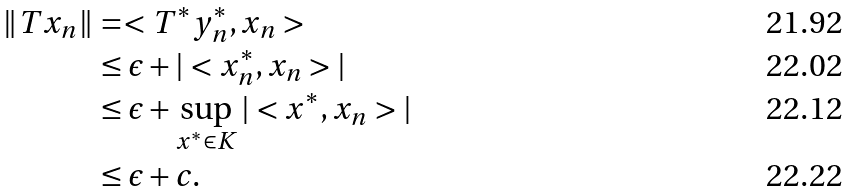Convert formula to latex. <formula><loc_0><loc_0><loc_500><loc_500>\| T x _ { n } \| & = < T ^ { * } y ^ { * } _ { n } , x _ { n } > \\ & \leq \epsilon + | < x ^ { * } _ { n } , x _ { n } > | \\ & \leq \epsilon + \sup _ { x ^ { * } \in K } | < x ^ { * } , x _ { n } > | \\ & \leq \epsilon + c .</formula> 